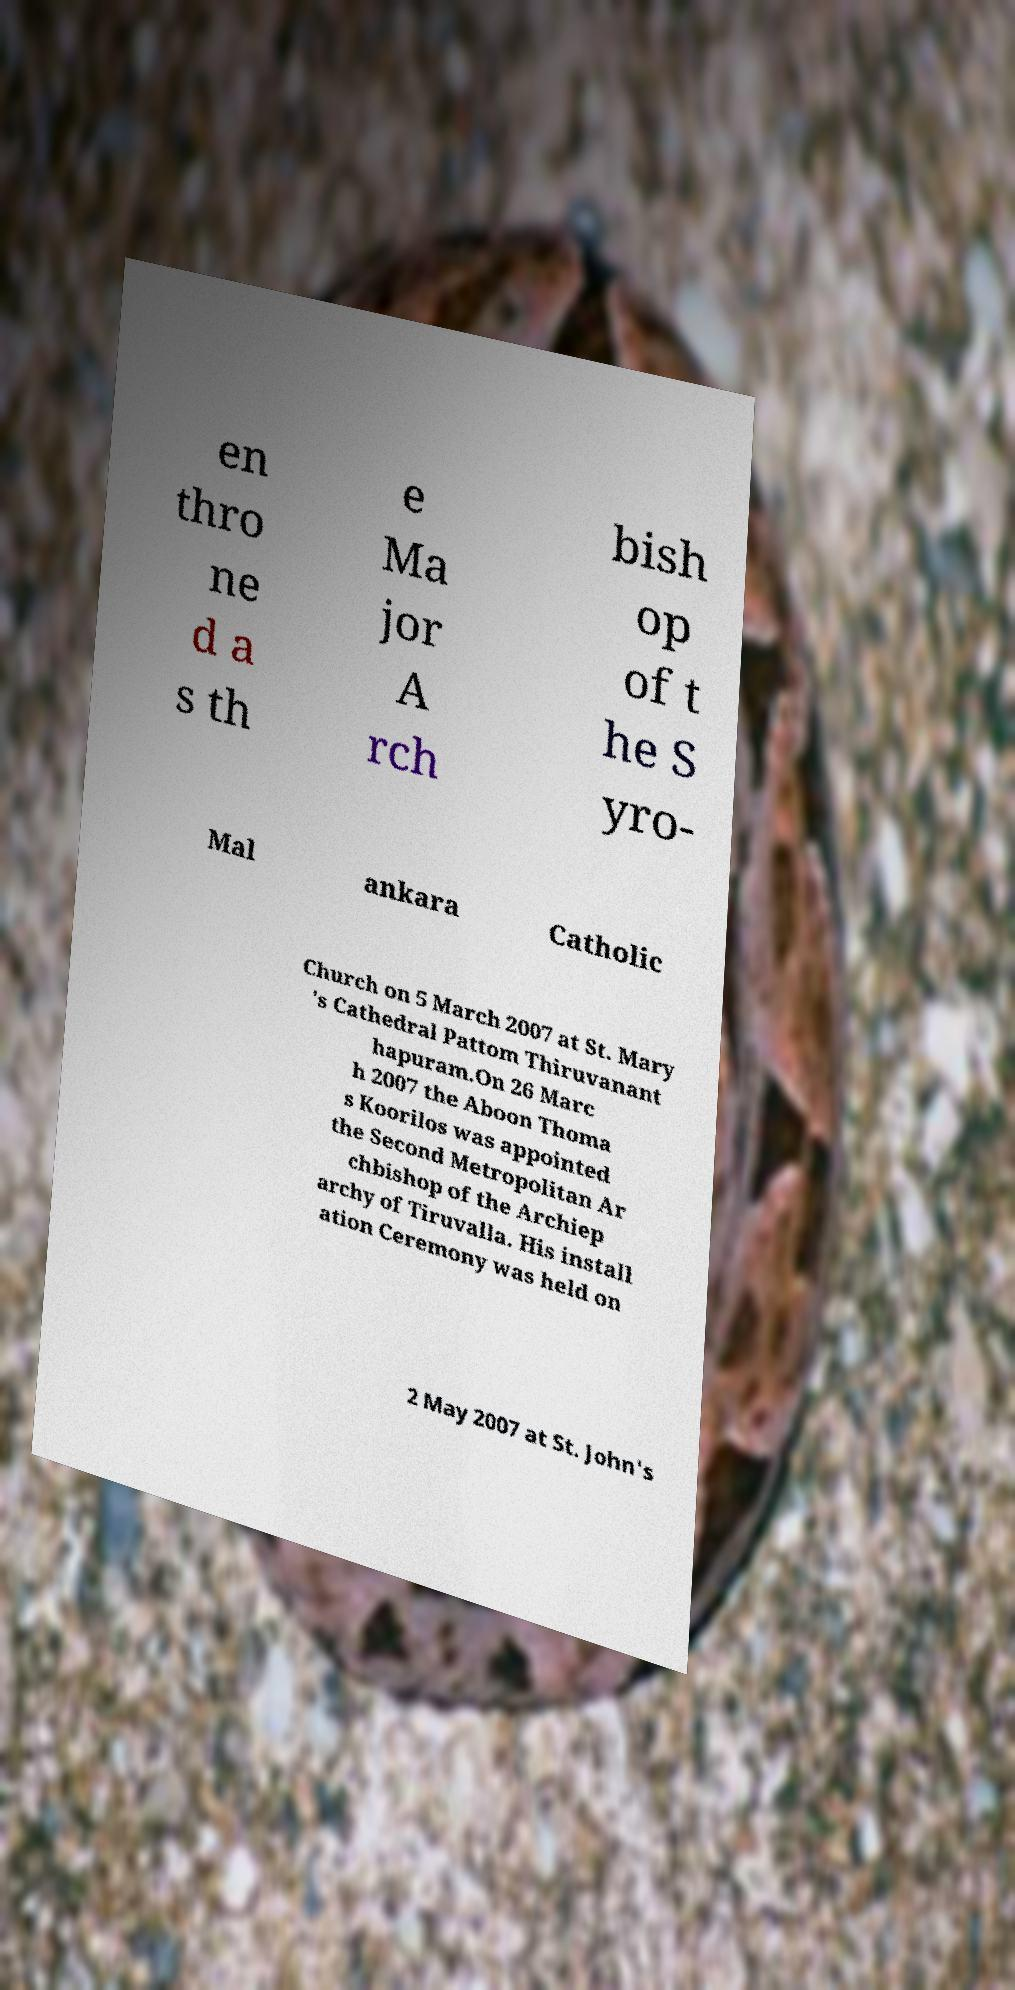There's text embedded in this image that I need extracted. Can you transcribe it verbatim? en thro ne d a s th e Ma jor A rch bish op of t he S yro- Mal ankara Catholic Church on 5 March 2007 at St. Mary 's Cathedral Pattom Thiruvanant hapuram.On 26 Marc h 2007 the Aboon Thoma s Koorilos was appointed the Second Metropolitan Ar chbishop of the Archiep archy of Tiruvalla. His install ation Ceremony was held on 2 May 2007 at St. John's 